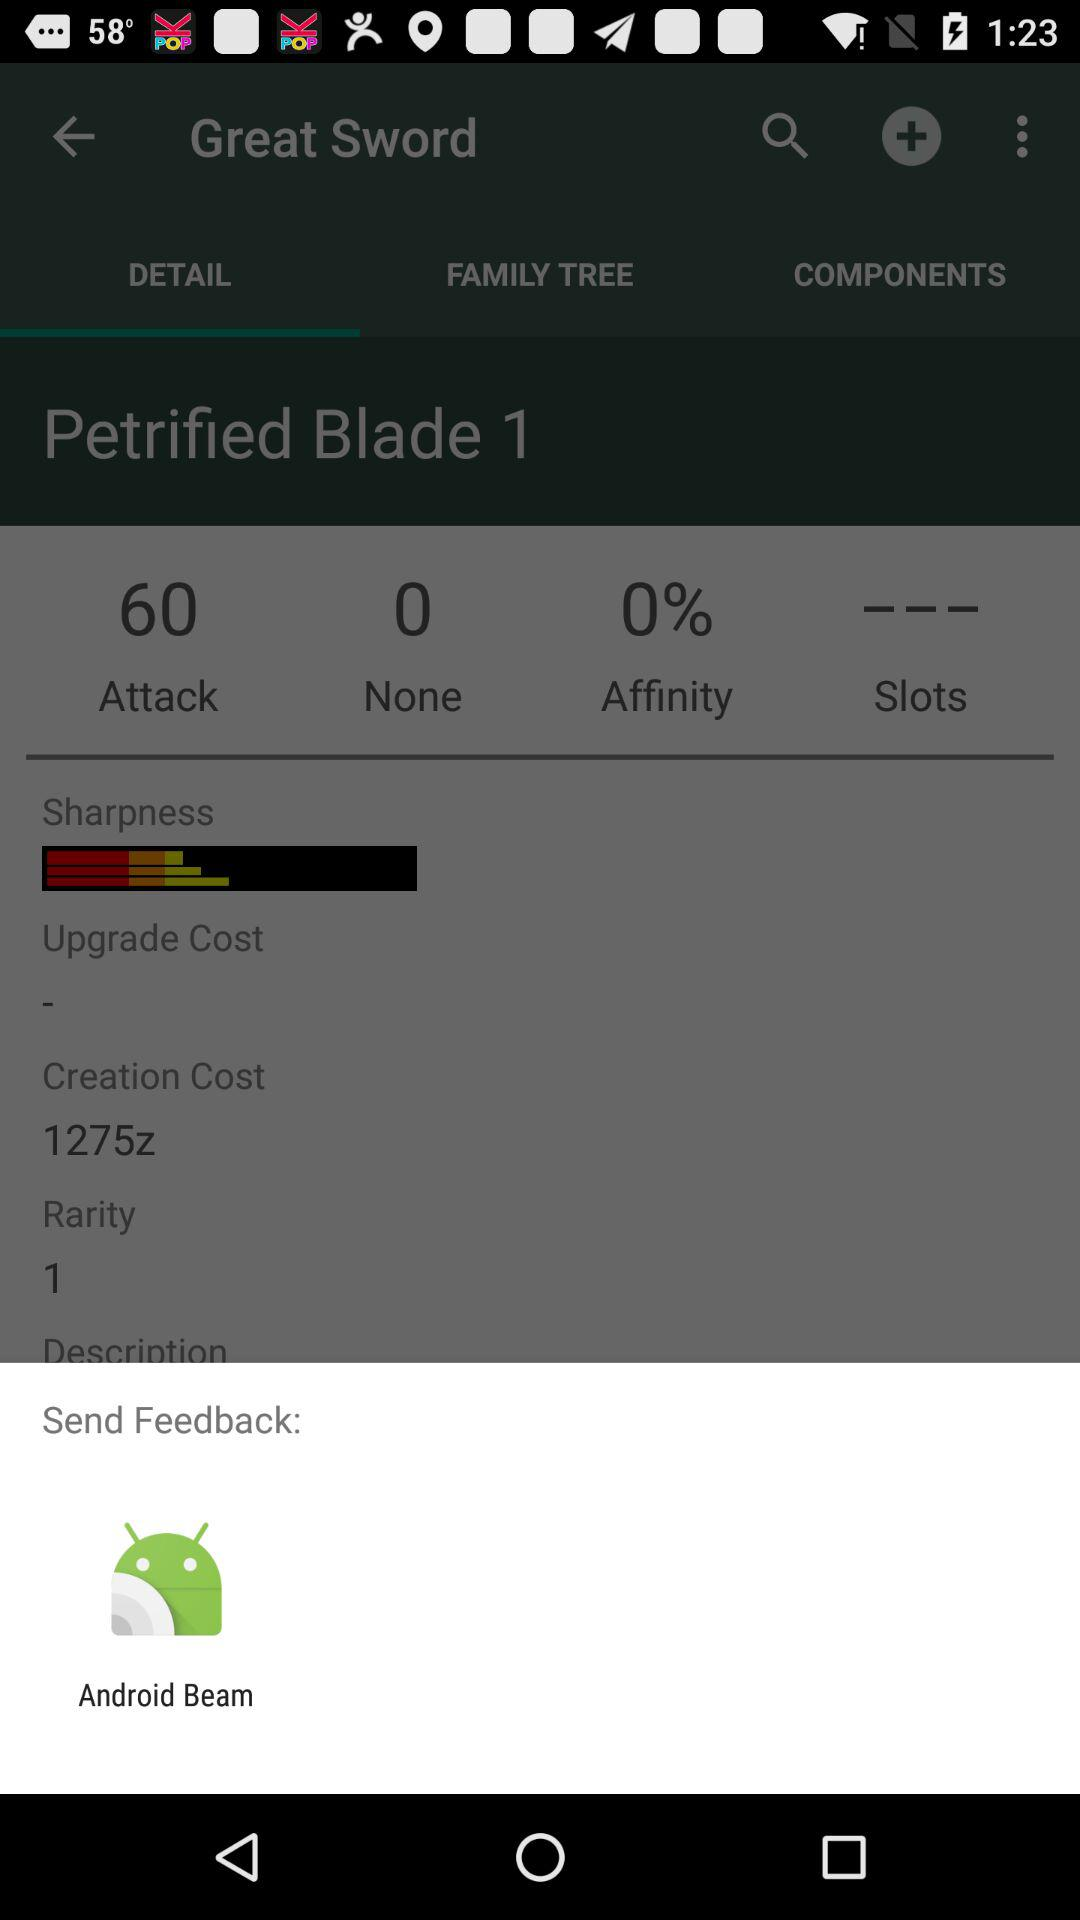What is the rarity of the Petrified Blade?
Answer the question using a single word or phrase. 1 